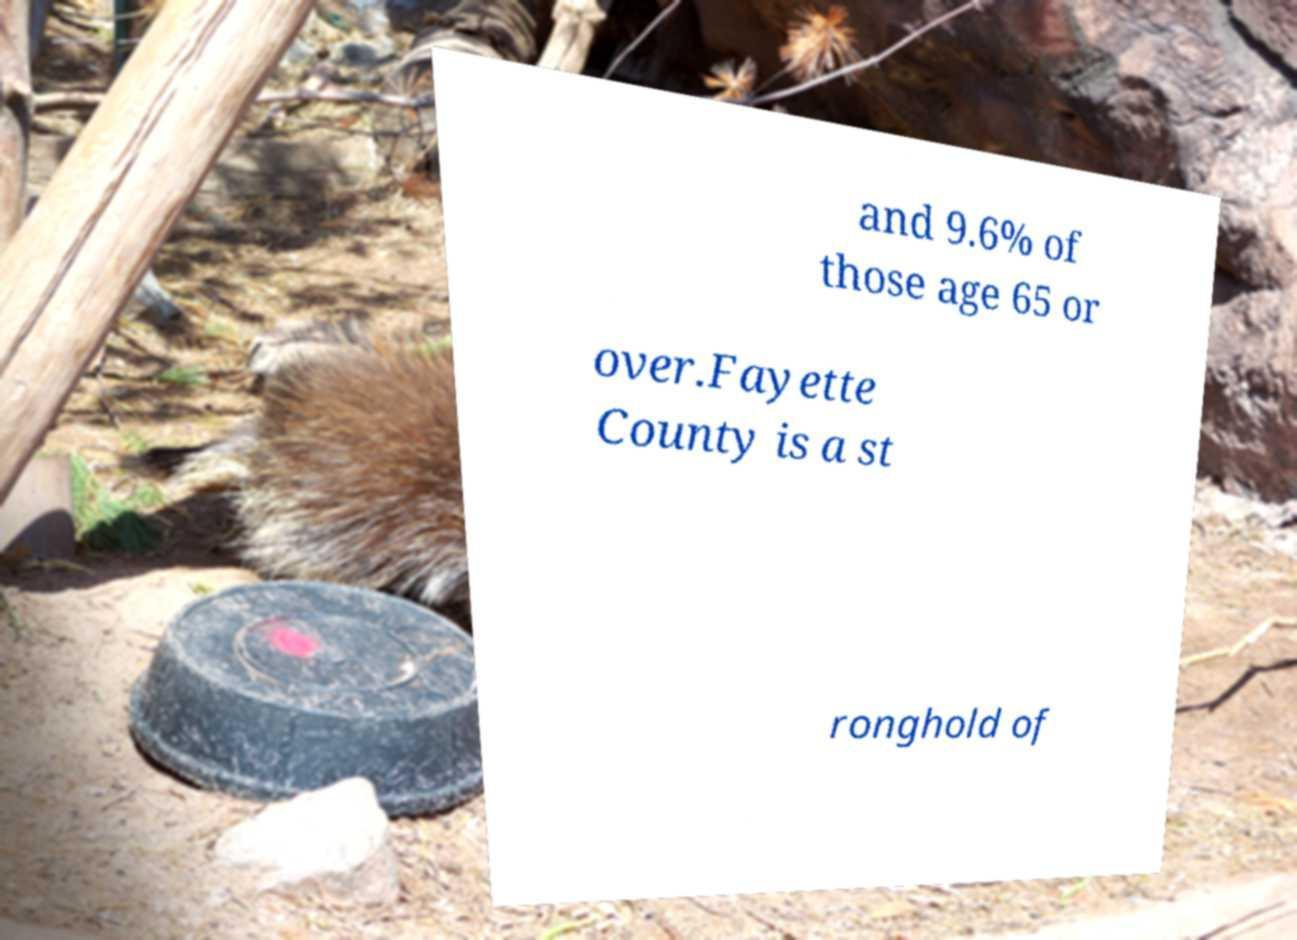Please identify and transcribe the text found in this image. and 9.6% of those age 65 or over.Fayette County is a st ronghold of 